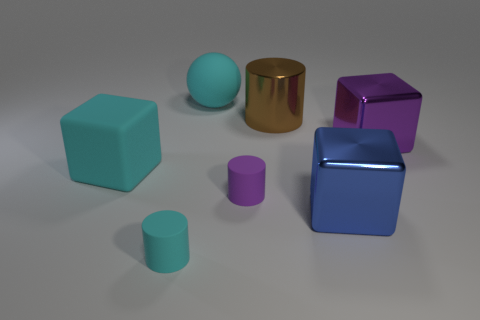Does the big rubber object that is left of the cyan rubber cylinder have the same color as the ball?
Provide a short and direct response. Yes. How many brown things are the same size as the cyan block?
Provide a succinct answer. 1. There is a blue object that is made of the same material as the large purple cube; what is its shape?
Make the answer very short. Cube. Are there any large matte objects of the same color as the large rubber block?
Your answer should be very brief. Yes. What is the cyan cylinder made of?
Your answer should be very brief. Rubber. How many things are either small purple rubber cylinders or big metal cylinders?
Your answer should be compact. 2. There is a cyan matte object that is right of the small cyan matte thing; how big is it?
Provide a short and direct response. Large. How many other things are there of the same material as the cyan cylinder?
Your answer should be compact. 3. There is a small matte cylinder to the left of the purple rubber object; is there a large purple cube behind it?
Provide a succinct answer. Yes. What color is the other big shiny object that is the same shape as the large purple object?
Offer a very short reply. Blue. 